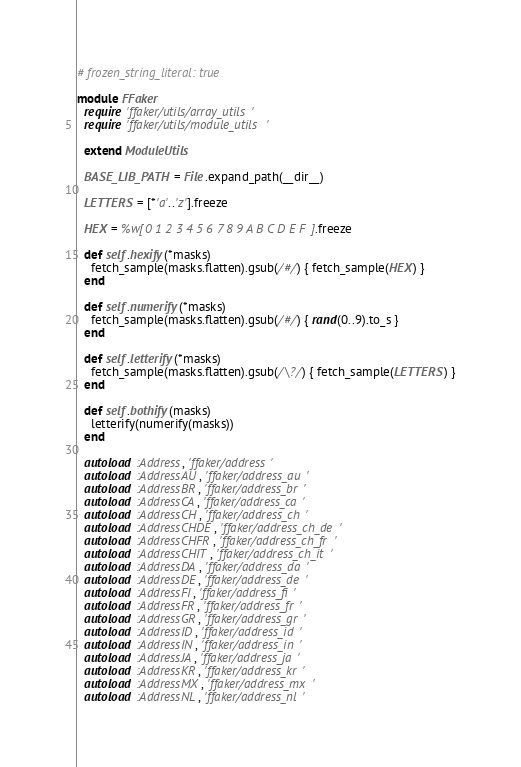Convert code to text. <code><loc_0><loc_0><loc_500><loc_500><_Ruby_># frozen_string_literal: true

module FFaker
  require 'ffaker/utils/array_utils'
  require 'ffaker/utils/module_utils'

  extend ModuleUtils

  BASE_LIB_PATH = File.expand_path(__dir__)

  LETTERS = [*'a'..'z'].freeze

  HEX = %w[0 1 2 3 4 5 6 7 8 9 A B C D E F].freeze

  def self.hexify(*masks)
    fetch_sample(masks.flatten).gsub(/#/) { fetch_sample(HEX) }
  end

  def self.numerify(*masks)
    fetch_sample(masks.flatten).gsub(/#/) { rand(0..9).to_s }
  end

  def self.letterify(*masks)
    fetch_sample(masks.flatten).gsub(/\?/) { fetch_sample(LETTERS) }
  end

  def self.bothify(masks)
    letterify(numerify(masks))
  end

  autoload :Address, 'ffaker/address'
  autoload :AddressAU, 'ffaker/address_au'
  autoload :AddressBR, 'ffaker/address_br'
  autoload :AddressCA, 'ffaker/address_ca'
  autoload :AddressCH, 'ffaker/address_ch'
  autoload :AddressCHDE, 'ffaker/address_ch_de'
  autoload :AddressCHFR, 'ffaker/address_ch_fr'
  autoload :AddressCHIT, 'ffaker/address_ch_it'
  autoload :AddressDA, 'ffaker/address_da'
  autoload :AddressDE, 'ffaker/address_de'
  autoload :AddressFI, 'ffaker/address_fi'
  autoload :AddressFR, 'ffaker/address_fr'
  autoload :AddressGR, 'ffaker/address_gr'
  autoload :AddressID, 'ffaker/address_id'
  autoload :AddressIN, 'ffaker/address_in'
  autoload :AddressJA, 'ffaker/address_ja'
  autoload :AddressKR, 'ffaker/address_kr'
  autoload :AddressMX, 'ffaker/address_mx'
  autoload :AddressNL, 'ffaker/address_nl'</code> 